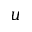<formula> <loc_0><loc_0><loc_500><loc_500>u</formula> 